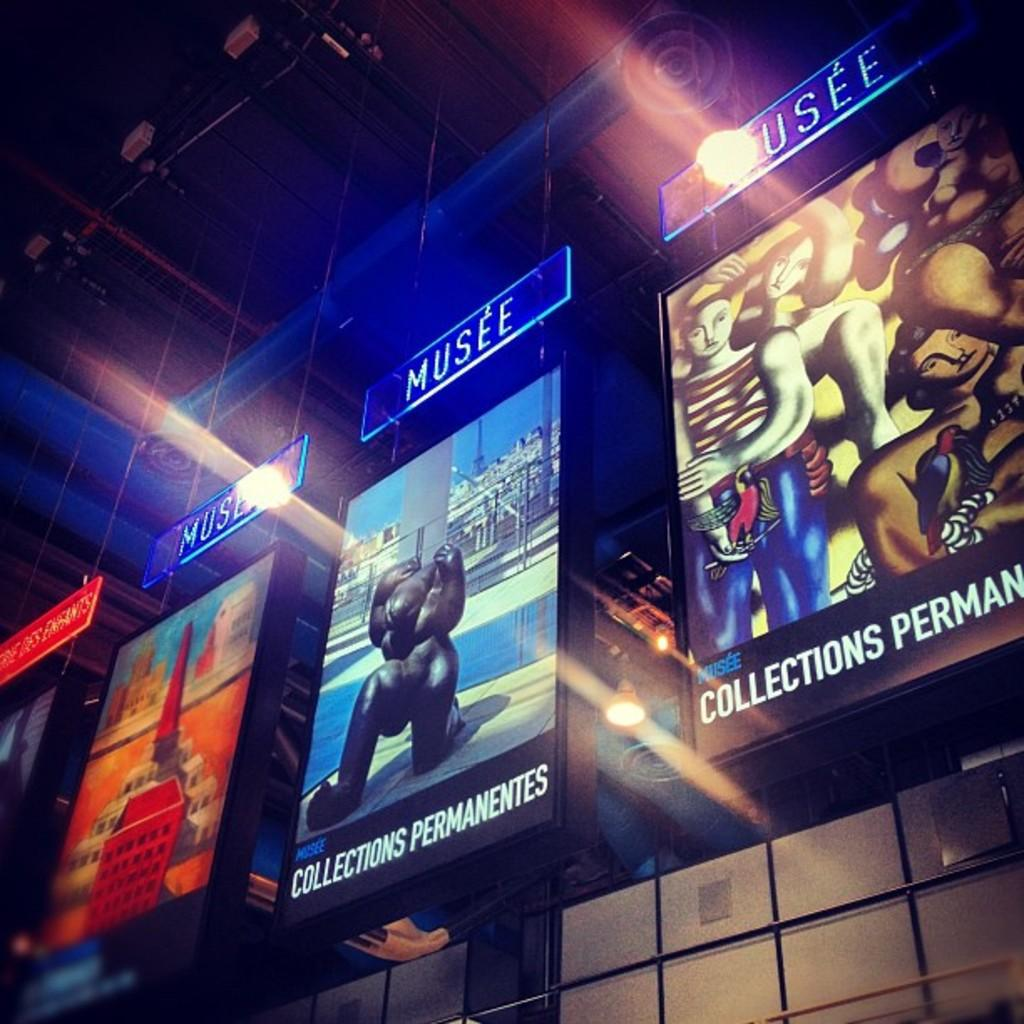<image>
Share a concise interpretation of the image provided. A series of large posters are hanging, each of which has the word musee hanging above them. 